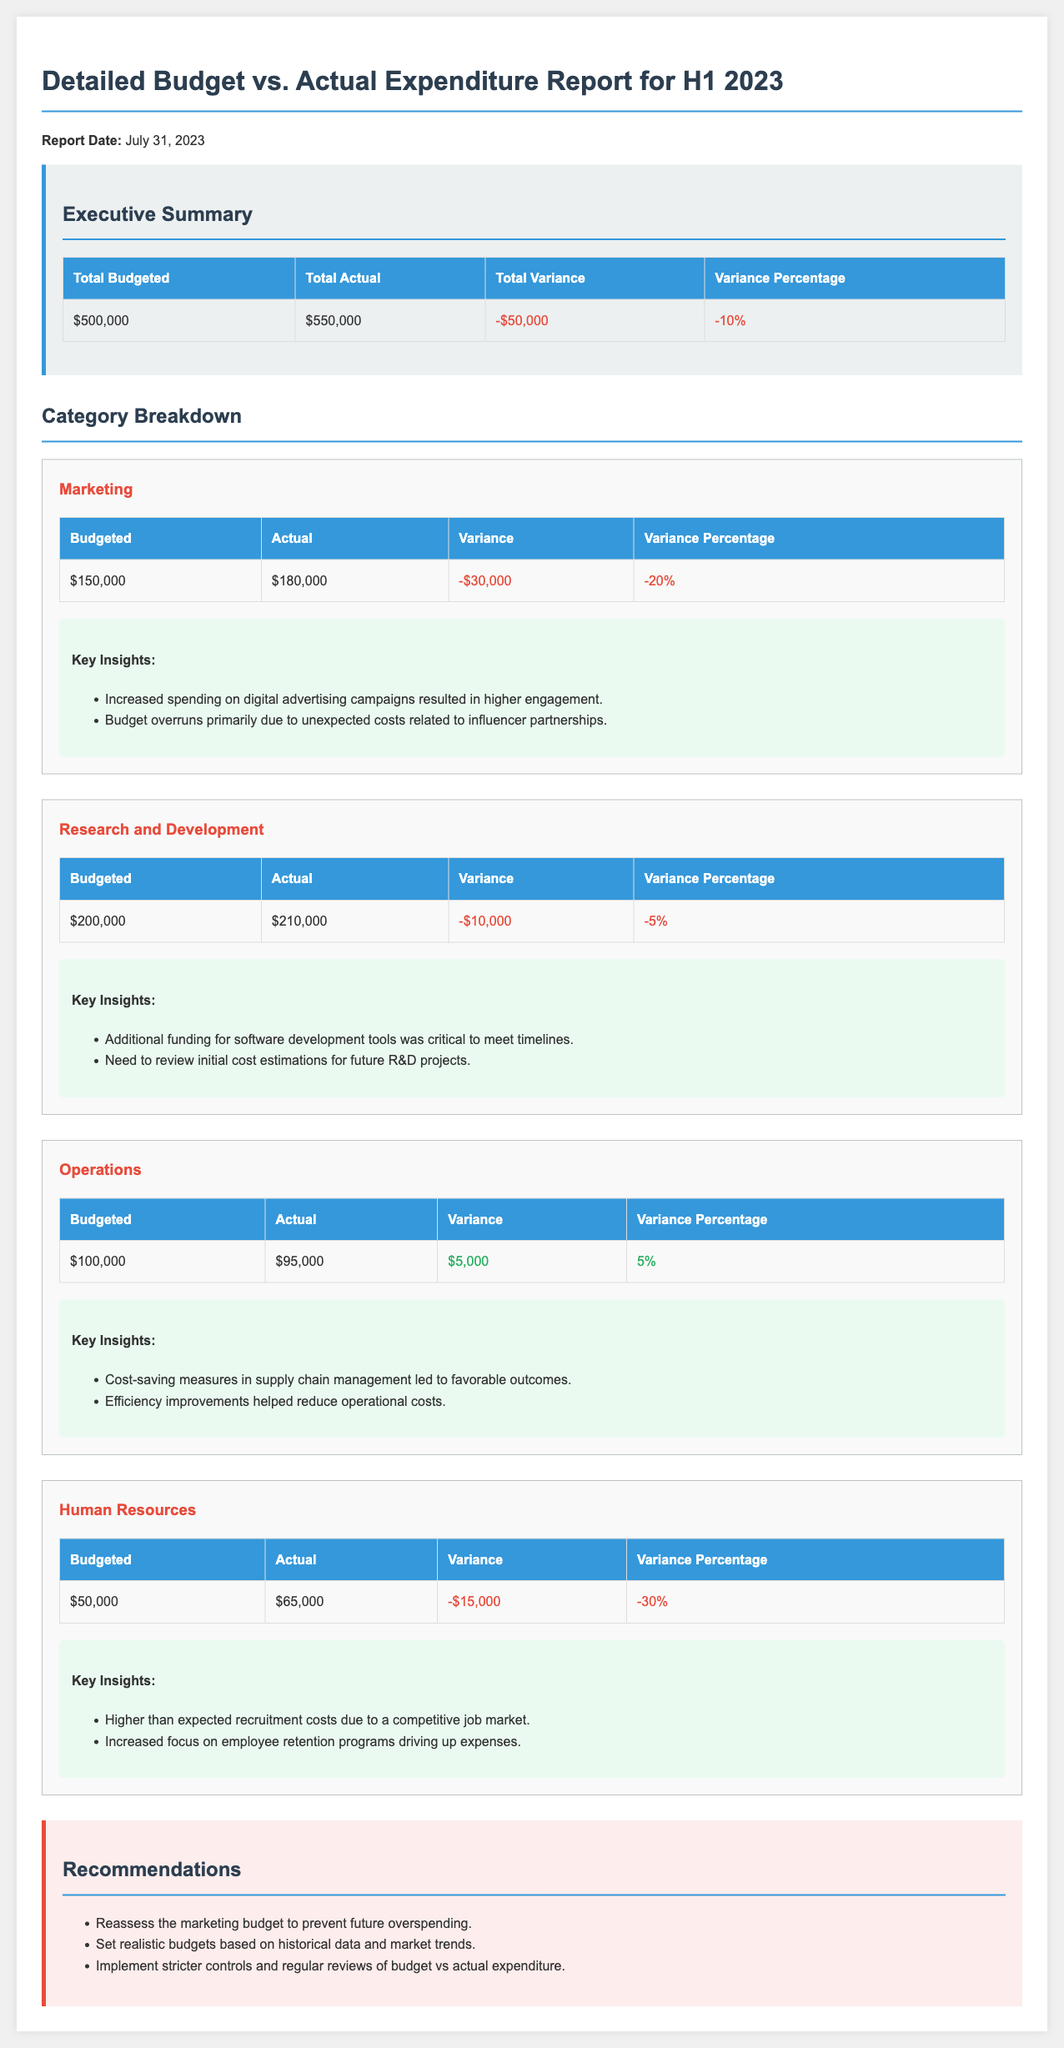What is the total budgeted amount for H1 2023? The total budgeted amount is shown in the executive summary table.
Answer: $500,000 What was the total actual expenditure for H1 2023? The total actual expenditure is provided in the executive summary table.
Answer: $550,000 What is the variance percentage for the marketing category? The variance percentage is indicated in the marketing category table.
Answer: -20% How much did the Human Resources category overspend? The overspending amount is detailed in the Human Resources category table.
Answer: -$15,000 What were the total savings in the Operations category? The savings amount is listed in the Operations category table as a positive variance.
Answer: $5,000 What is the key insight related to Research and Development? The insight is summarised in the insights section of the R&D category.
Answer: Additional funding for software development tools was critical to meet timelines What recommendation is made regarding the marketing budget? Recommendations are provided in a separate section at the end of the report.
Answer: Reassess the marketing budget to prevent future overspending When was this report generated? The report date is stated at the top of the document.
Answer: July 31, 2023 What was the total variance for the first half of 2023? The total variance is presented in the executive summary table.
Answer: -$50,000 